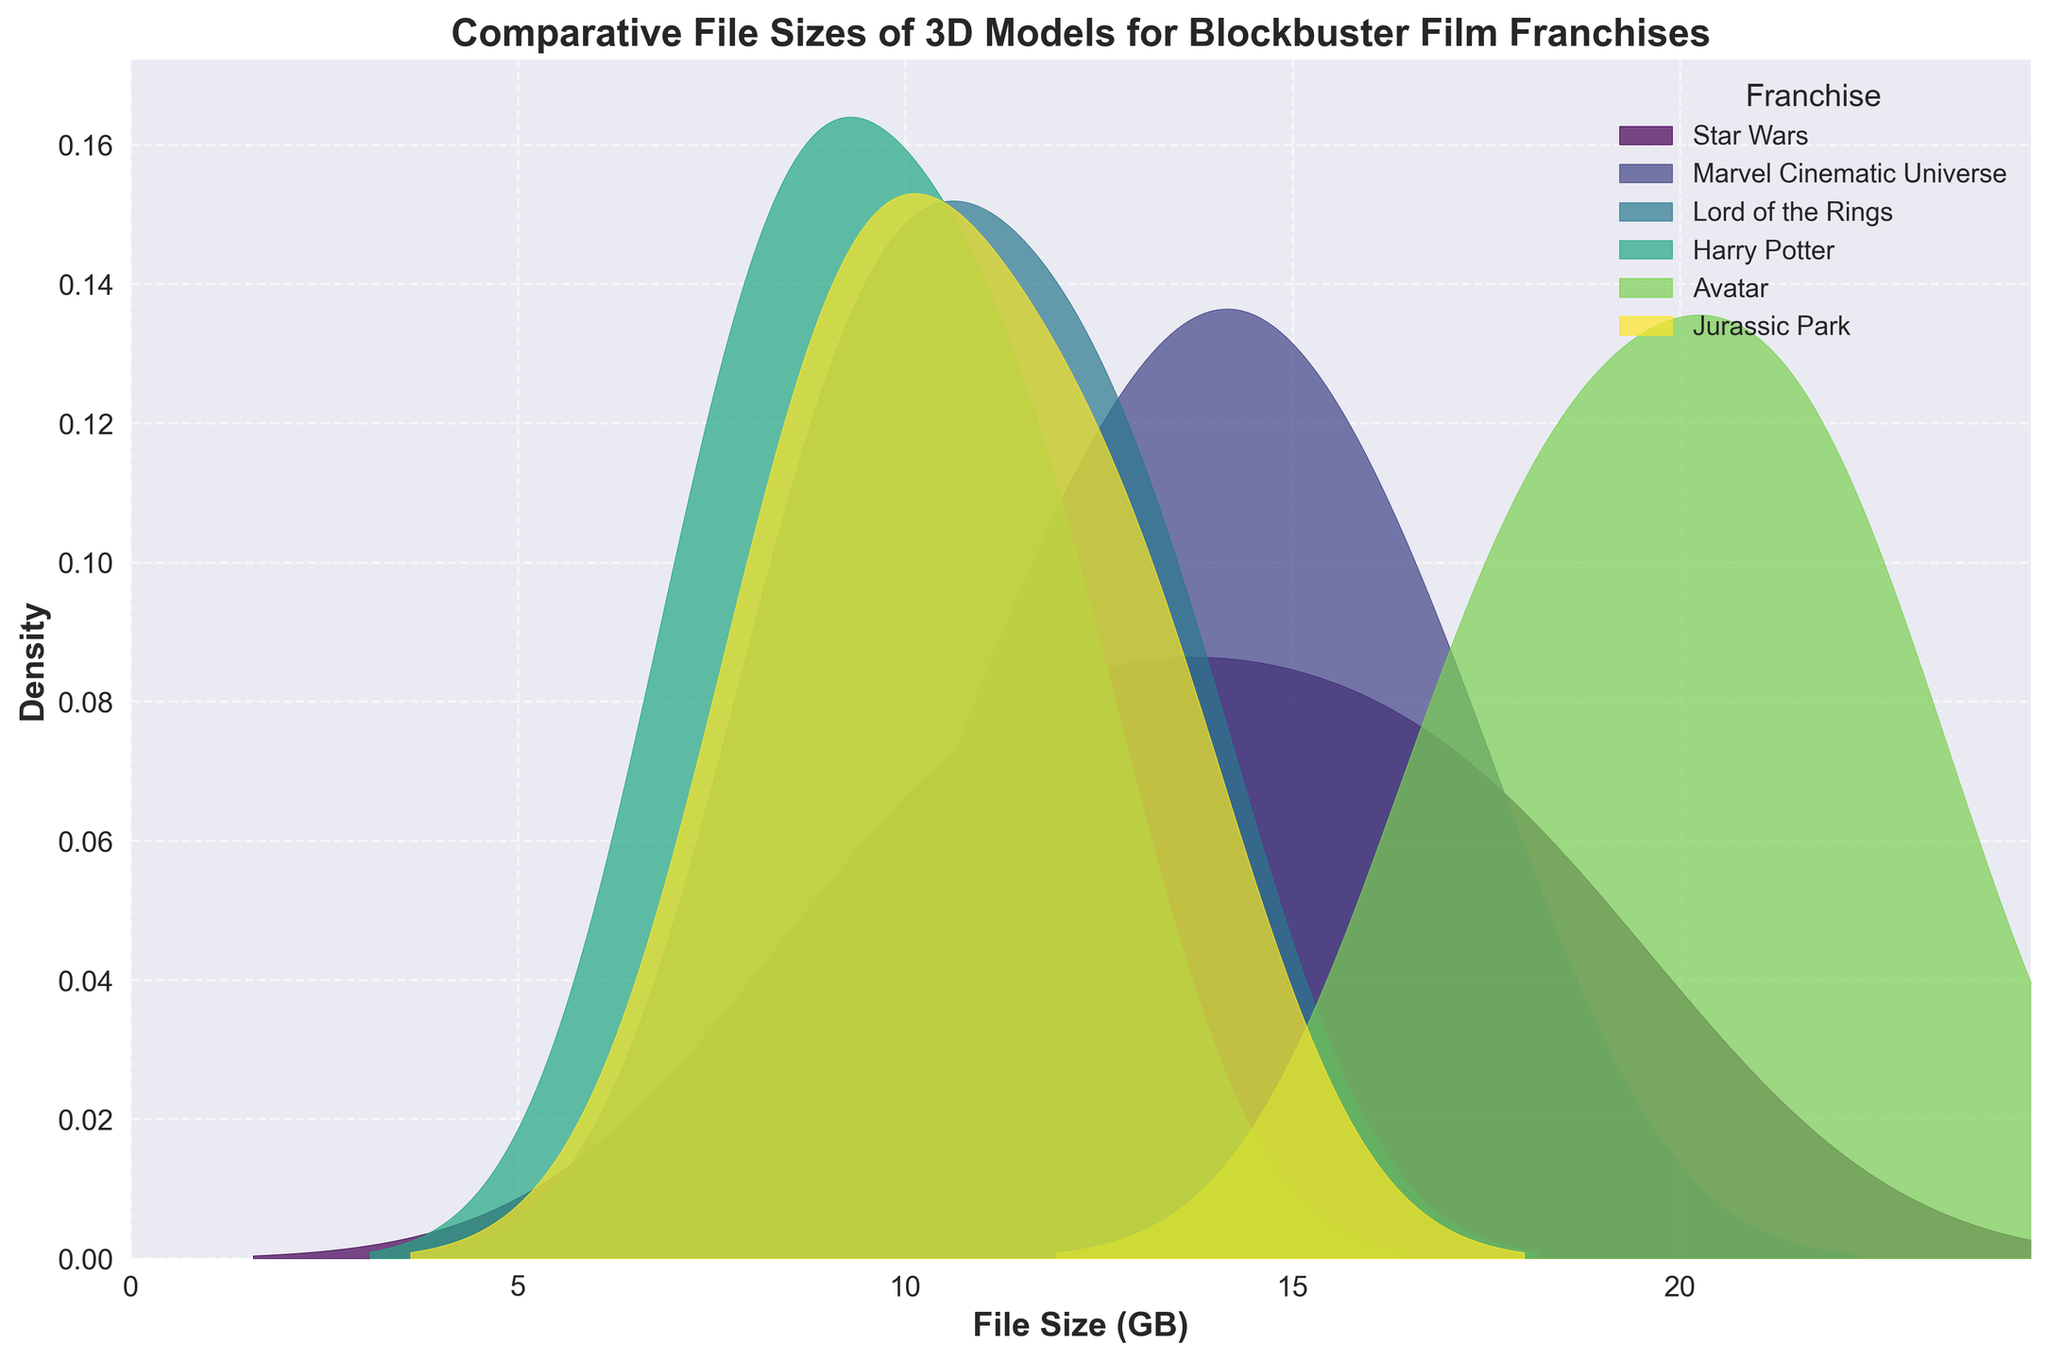What is the title of the plot? The title of the plot is located at the top center and provides an overview of what the plot is about.
Answer: Comparative File Sizes of 3D Models for Blockbuster Film Franchises Which franchise has the widest distribution of file sizes? By comparing the width of the distributions for each franchise, we see which spreads over the largest range of values.
Answer: Avatar Which franchise has the highest peak density? The highest peak density corresponds to the tallest point in the density plot for each franchise.
Answer: Marvel Cinematic Universe Between "Star Wars" and "Harry Potter," which franchise has larger file sizes on average? By visual inspection, the peak density for Star Wars is at a higher file size compared to Harry Potter's peak, indicating that Star Wars has larger file sizes on average.
Answer: Star Wars Are there any overlapping regions in the density distributions of "Jurassic Park" and "Lord of the Rings"? Check the regions in the density plot where the densities of "Jurassic Park" and "Lord of the Rings" intersect or overlap.
Answer: Yes What file size range is most common for "Avatar" models? The most common file size range for a franchise is indicated by the peak density in that range.
Answer: 17.6 to 22.3 GB Which franchise has the smallest file sizes? Look for the franchise whose peak density is at the lowest range of file sizes.
Answer: Harry Potter Compare the distributions of "Star Wars" and "Marvel Cinematic Universe." Which has more varied file sizes? The variation can be gauged by looking at the spread of the distributions; "Star Wars" has a more varied distribution compared to "Marvel Cinematic Universe."
Answer: Star Wars What is the approximate highest file size observed for "Lord of the Rings"? The highest file size is determined by observing the farthest right point of the density distribution for "Lord of the Rings."
Answer: Around 13.1 GB 